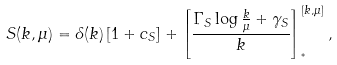<formula> <loc_0><loc_0><loc_500><loc_500>S ( k , \mu ) = \delta ( k ) \left [ 1 + c _ { S } \right ] + \left [ \frac { \Gamma _ { S } \log \frac { k } { \mu } + \gamma _ { S } } { k } \right ] ^ { [ k , \mu ] } _ { ^ { * } } ,</formula> 